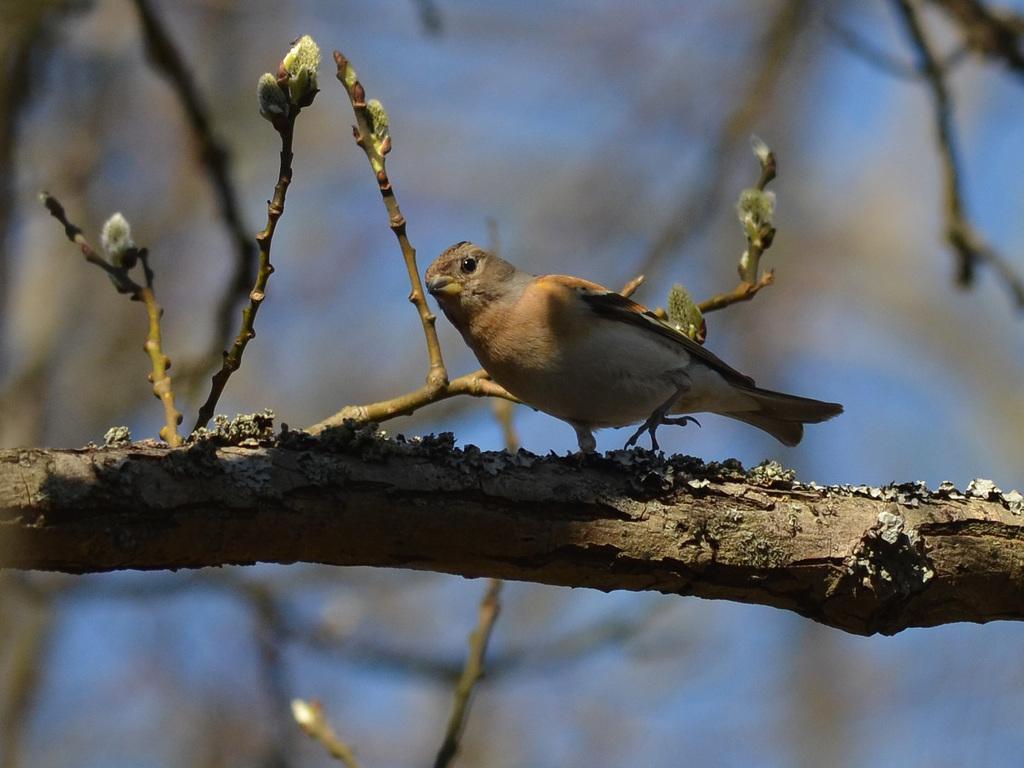In one or two sentences, can you explain what this image depicts? In this image in the foreground there is one bird on the tree, in the background there are some trees and sky. 